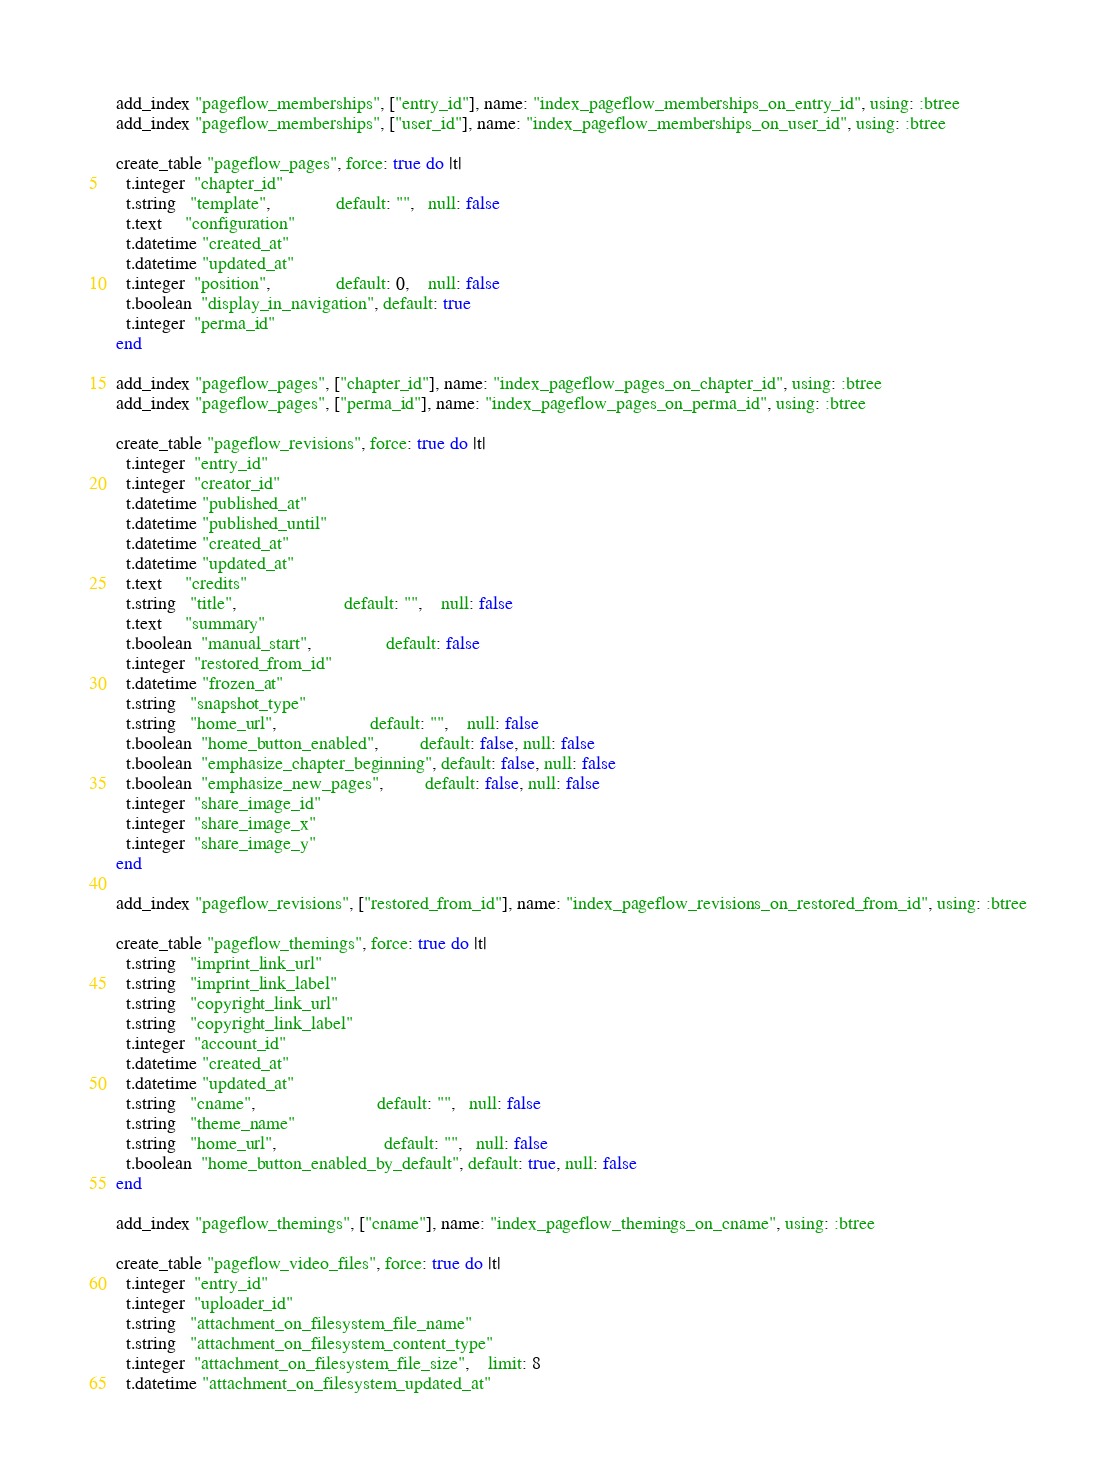<code> <loc_0><loc_0><loc_500><loc_500><_Ruby_>  add_index "pageflow_memberships", ["entry_id"], name: "index_pageflow_memberships_on_entry_id", using: :btree
  add_index "pageflow_memberships", ["user_id"], name: "index_pageflow_memberships_on_user_id", using: :btree

  create_table "pageflow_pages", force: true do |t|
    t.integer  "chapter_id"
    t.string   "template",              default: "",   null: false
    t.text     "configuration"
    t.datetime "created_at"
    t.datetime "updated_at"
    t.integer  "position",              default: 0,    null: false
    t.boolean  "display_in_navigation", default: true
    t.integer  "perma_id"
  end

  add_index "pageflow_pages", ["chapter_id"], name: "index_pageflow_pages_on_chapter_id", using: :btree
  add_index "pageflow_pages", ["perma_id"], name: "index_pageflow_pages_on_perma_id", using: :btree

  create_table "pageflow_revisions", force: true do |t|
    t.integer  "entry_id"
    t.integer  "creator_id"
    t.datetime "published_at"
    t.datetime "published_until"
    t.datetime "created_at"
    t.datetime "updated_at"
    t.text     "credits"
    t.string   "title",                       default: "",    null: false
    t.text     "summary"
    t.boolean  "manual_start",                default: false
    t.integer  "restored_from_id"
    t.datetime "frozen_at"
    t.string   "snapshot_type"
    t.string   "home_url",                    default: "",    null: false
    t.boolean  "home_button_enabled",         default: false, null: false
    t.boolean  "emphasize_chapter_beginning", default: false, null: false
    t.boolean  "emphasize_new_pages",         default: false, null: false
    t.integer  "share_image_id"
    t.integer  "share_image_x"
    t.integer  "share_image_y"
  end

  add_index "pageflow_revisions", ["restored_from_id"], name: "index_pageflow_revisions_on_restored_from_id", using: :btree

  create_table "pageflow_themings", force: true do |t|
    t.string   "imprint_link_url"
    t.string   "imprint_link_label"
    t.string   "copyright_link_url"
    t.string   "copyright_link_label"
    t.integer  "account_id"
    t.datetime "created_at"
    t.datetime "updated_at"
    t.string   "cname",                          default: "",   null: false
    t.string   "theme_name"
    t.string   "home_url",                       default: "",   null: false
    t.boolean  "home_button_enabled_by_default", default: true, null: false
  end

  add_index "pageflow_themings", ["cname"], name: "index_pageflow_themings_on_cname", using: :btree

  create_table "pageflow_video_files", force: true do |t|
    t.integer  "entry_id"
    t.integer  "uploader_id"
    t.string   "attachment_on_filesystem_file_name"
    t.string   "attachment_on_filesystem_content_type"
    t.integer  "attachment_on_filesystem_file_size",    limit: 8
    t.datetime "attachment_on_filesystem_updated_at"</code> 